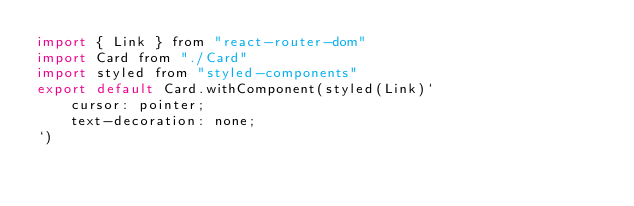Convert code to text. <code><loc_0><loc_0><loc_500><loc_500><_JavaScript_>import { Link } from "react-router-dom"
import Card from "./Card"
import styled from "styled-components"
export default Card.withComponent(styled(Link)`
	cursor: pointer;
	text-decoration: none;
`)
</code> 